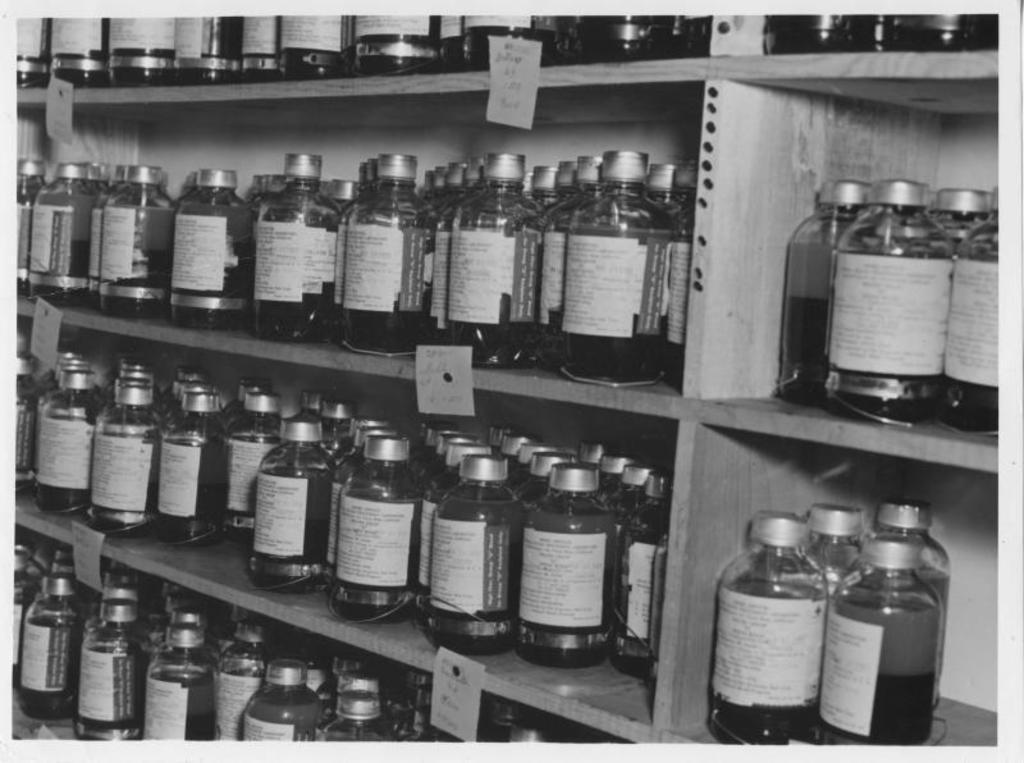Describe this image in one or two sentences. This is a black and white image. There are shelves and bottles are in the shelves. There is some liquid in that bottle. 